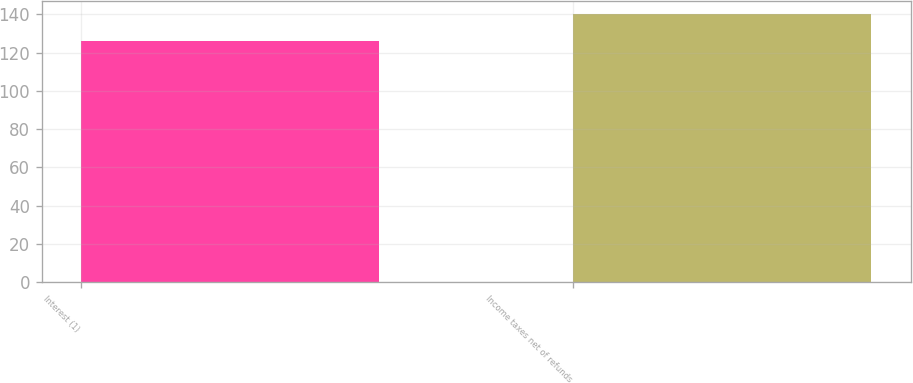Convert chart to OTSL. <chart><loc_0><loc_0><loc_500><loc_500><bar_chart><fcel>Interest (1)<fcel>Income taxes net of refunds<nl><fcel>126<fcel>140<nl></chart> 